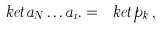<formula> <loc_0><loc_0><loc_500><loc_500>\ k e t { a _ { N } \dots a _ { 1 } . } = \ k e t { p _ { k } } \, ,</formula> 